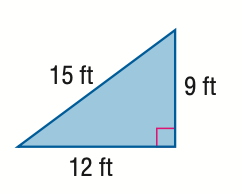Answer the mathemtical geometry problem and directly provide the correct option letter.
Question: Find the perimeter of the triangle. Round to the nearest tenth if necessary.
Choices: A: 21 B: 24 C: 36 D: 54 C 